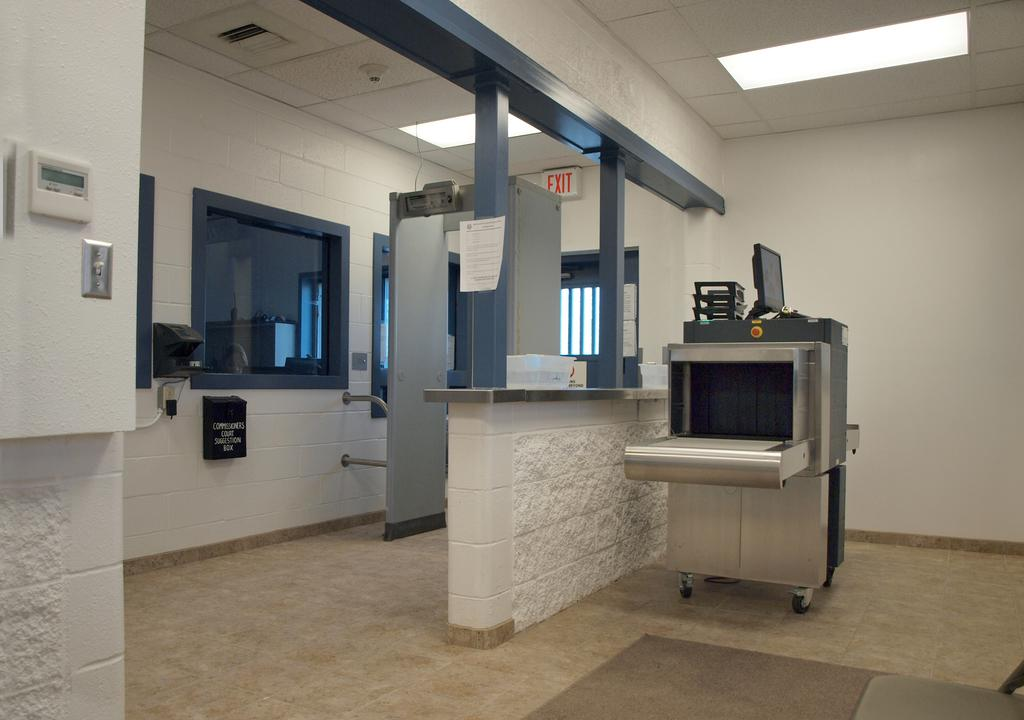<image>
Provide a brief description of the given image. a building with white walls and blue borders, and a white and red exit sign above the door 